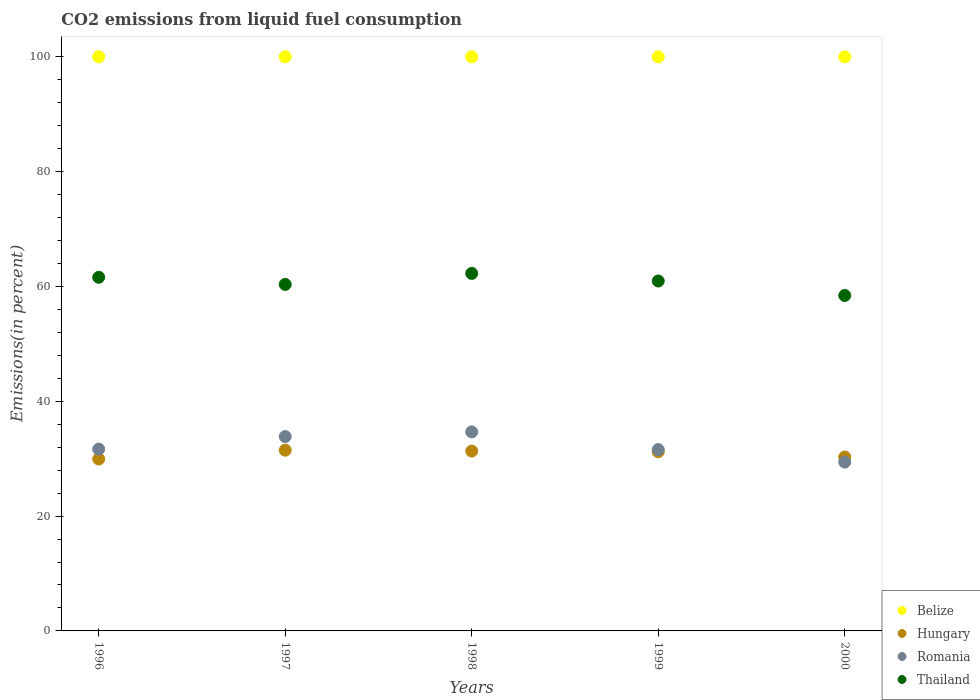Is the number of dotlines equal to the number of legend labels?
Your response must be concise. Yes. What is the total CO2 emitted in Thailand in 1996?
Your response must be concise. 61.6. In which year was the total CO2 emitted in Romania maximum?
Make the answer very short. 1998. What is the total total CO2 emitted in Thailand in the graph?
Make the answer very short. 303.62. What is the difference between the total CO2 emitted in Thailand in 1997 and that in 1999?
Your answer should be very brief. -0.59. What is the difference between the total CO2 emitted in Hungary in 1997 and the total CO2 emitted in Belize in 1996?
Make the answer very short. -68.52. In the year 1996, what is the difference between the total CO2 emitted in Romania and total CO2 emitted in Hungary?
Offer a very short reply. 1.72. What is the ratio of the total CO2 emitted in Thailand in 1999 to that in 2000?
Ensure brevity in your answer.  1.04. Is the total CO2 emitted in Thailand in 1999 less than that in 2000?
Provide a succinct answer. No. What is the difference between the highest and the second highest total CO2 emitted in Hungary?
Offer a terse response. 0.16. What is the difference between the highest and the lowest total CO2 emitted in Thailand?
Ensure brevity in your answer.  3.84. Is the sum of the total CO2 emitted in Belize in 1997 and 1998 greater than the maximum total CO2 emitted in Hungary across all years?
Provide a short and direct response. Yes. Is it the case that in every year, the sum of the total CO2 emitted in Hungary and total CO2 emitted in Thailand  is greater than the sum of total CO2 emitted in Romania and total CO2 emitted in Belize?
Your answer should be compact. Yes. Does the total CO2 emitted in Belize monotonically increase over the years?
Make the answer very short. No. Is the total CO2 emitted in Hungary strictly less than the total CO2 emitted in Thailand over the years?
Your answer should be compact. Yes. How many dotlines are there?
Give a very brief answer. 4. What is the difference between two consecutive major ticks on the Y-axis?
Ensure brevity in your answer.  20. Are the values on the major ticks of Y-axis written in scientific E-notation?
Offer a very short reply. No. Does the graph contain any zero values?
Give a very brief answer. No. Does the graph contain grids?
Provide a succinct answer. No. What is the title of the graph?
Your answer should be very brief. CO2 emissions from liquid fuel consumption. Does "Slovenia" appear as one of the legend labels in the graph?
Offer a very short reply. No. What is the label or title of the Y-axis?
Your answer should be very brief. Emissions(in percent). What is the Emissions(in percent) of Hungary in 1996?
Your answer should be compact. 29.95. What is the Emissions(in percent) in Romania in 1996?
Make the answer very short. 31.67. What is the Emissions(in percent) of Thailand in 1996?
Keep it short and to the point. 61.6. What is the Emissions(in percent) of Belize in 1997?
Make the answer very short. 100. What is the Emissions(in percent) of Hungary in 1997?
Your response must be concise. 31.48. What is the Emissions(in percent) of Romania in 1997?
Your answer should be very brief. 33.85. What is the Emissions(in percent) in Thailand in 1997?
Provide a short and direct response. 60.36. What is the Emissions(in percent) in Hungary in 1998?
Keep it short and to the point. 31.33. What is the Emissions(in percent) in Romania in 1998?
Offer a terse response. 34.67. What is the Emissions(in percent) in Thailand in 1998?
Provide a succinct answer. 62.27. What is the Emissions(in percent) in Belize in 1999?
Your answer should be compact. 100. What is the Emissions(in percent) in Hungary in 1999?
Make the answer very short. 31.21. What is the Emissions(in percent) in Romania in 1999?
Offer a very short reply. 31.59. What is the Emissions(in percent) of Thailand in 1999?
Keep it short and to the point. 60.95. What is the Emissions(in percent) in Belize in 2000?
Make the answer very short. 100. What is the Emissions(in percent) of Hungary in 2000?
Your response must be concise. 30.3. What is the Emissions(in percent) in Romania in 2000?
Give a very brief answer. 29.41. What is the Emissions(in percent) in Thailand in 2000?
Your answer should be very brief. 58.43. Across all years, what is the maximum Emissions(in percent) in Hungary?
Provide a short and direct response. 31.48. Across all years, what is the maximum Emissions(in percent) in Romania?
Keep it short and to the point. 34.67. Across all years, what is the maximum Emissions(in percent) in Thailand?
Give a very brief answer. 62.27. Across all years, what is the minimum Emissions(in percent) of Hungary?
Provide a short and direct response. 29.95. Across all years, what is the minimum Emissions(in percent) of Romania?
Your answer should be very brief. 29.41. Across all years, what is the minimum Emissions(in percent) of Thailand?
Your answer should be compact. 58.43. What is the total Emissions(in percent) of Hungary in the graph?
Ensure brevity in your answer.  154.27. What is the total Emissions(in percent) of Romania in the graph?
Keep it short and to the point. 161.19. What is the total Emissions(in percent) in Thailand in the graph?
Your answer should be compact. 303.62. What is the difference between the Emissions(in percent) in Hungary in 1996 and that in 1997?
Offer a very short reply. -1.54. What is the difference between the Emissions(in percent) in Romania in 1996 and that in 1997?
Provide a short and direct response. -2.19. What is the difference between the Emissions(in percent) in Thailand in 1996 and that in 1997?
Your answer should be compact. 1.24. What is the difference between the Emissions(in percent) of Belize in 1996 and that in 1998?
Give a very brief answer. 0. What is the difference between the Emissions(in percent) in Hungary in 1996 and that in 1998?
Ensure brevity in your answer.  -1.38. What is the difference between the Emissions(in percent) of Romania in 1996 and that in 1998?
Keep it short and to the point. -3. What is the difference between the Emissions(in percent) of Thailand in 1996 and that in 1998?
Offer a very short reply. -0.68. What is the difference between the Emissions(in percent) in Hungary in 1996 and that in 1999?
Your response must be concise. -1.27. What is the difference between the Emissions(in percent) of Romania in 1996 and that in 1999?
Offer a very short reply. 0.08. What is the difference between the Emissions(in percent) in Thailand in 1996 and that in 1999?
Your response must be concise. 0.65. What is the difference between the Emissions(in percent) of Hungary in 1996 and that in 2000?
Offer a very short reply. -0.35. What is the difference between the Emissions(in percent) of Romania in 1996 and that in 2000?
Make the answer very short. 2.26. What is the difference between the Emissions(in percent) of Thailand in 1996 and that in 2000?
Give a very brief answer. 3.17. What is the difference between the Emissions(in percent) in Belize in 1997 and that in 1998?
Make the answer very short. 0. What is the difference between the Emissions(in percent) of Hungary in 1997 and that in 1998?
Ensure brevity in your answer.  0.16. What is the difference between the Emissions(in percent) of Romania in 1997 and that in 1998?
Make the answer very short. -0.82. What is the difference between the Emissions(in percent) in Thailand in 1997 and that in 1998?
Keep it short and to the point. -1.92. What is the difference between the Emissions(in percent) of Belize in 1997 and that in 1999?
Your answer should be very brief. 0. What is the difference between the Emissions(in percent) in Hungary in 1997 and that in 1999?
Make the answer very short. 0.27. What is the difference between the Emissions(in percent) of Romania in 1997 and that in 1999?
Provide a succinct answer. 2.27. What is the difference between the Emissions(in percent) in Thailand in 1997 and that in 1999?
Ensure brevity in your answer.  -0.59. What is the difference between the Emissions(in percent) in Hungary in 1997 and that in 2000?
Provide a short and direct response. 1.19. What is the difference between the Emissions(in percent) of Romania in 1997 and that in 2000?
Make the answer very short. 4.44. What is the difference between the Emissions(in percent) in Thailand in 1997 and that in 2000?
Make the answer very short. 1.93. What is the difference between the Emissions(in percent) in Hungary in 1998 and that in 1999?
Give a very brief answer. 0.11. What is the difference between the Emissions(in percent) of Romania in 1998 and that in 1999?
Your answer should be compact. 3.09. What is the difference between the Emissions(in percent) of Thailand in 1998 and that in 1999?
Your answer should be very brief. 1.32. What is the difference between the Emissions(in percent) of Belize in 1998 and that in 2000?
Offer a terse response. 0. What is the difference between the Emissions(in percent) in Hungary in 1998 and that in 2000?
Your answer should be very brief. 1.03. What is the difference between the Emissions(in percent) in Romania in 1998 and that in 2000?
Your response must be concise. 5.26. What is the difference between the Emissions(in percent) in Thailand in 1998 and that in 2000?
Your response must be concise. 3.84. What is the difference between the Emissions(in percent) in Belize in 1999 and that in 2000?
Provide a short and direct response. 0. What is the difference between the Emissions(in percent) in Hungary in 1999 and that in 2000?
Your answer should be compact. 0.92. What is the difference between the Emissions(in percent) of Romania in 1999 and that in 2000?
Offer a very short reply. 2.17. What is the difference between the Emissions(in percent) of Thailand in 1999 and that in 2000?
Your answer should be compact. 2.52. What is the difference between the Emissions(in percent) in Belize in 1996 and the Emissions(in percent) in Hungary in 1997?
Provide a succinct answer. 68.52. What is the difference between the Emissions(in percent) in Belize in 1996 and the Emissions(in percent) in Romania in 1997?
Offer a very short reply. 66.15. What is the difference between the Emissions(in percent) of Belize in 1996 and the Emissions(in percent) of Thailand in 1997?
Offer a terse response. 39.64. What is the difference between the Emissions(in percent) in Hungary in 1996 and the Emissions(in percent) in Romania in 1997?
Make the answer very short. -3.91. What is the difference between the Emissions(in percent) in Hungary in 1996 and the Emissions(in percent) in Thailand in 1997?
Keep it short and to the point. -30.41. What is the difference between the Emissions(in percent) in Romania in 1996 and the Emissions(in percent) in Thailand in 1997?
Provide a succinct answer. -28.69. What is the difference between the Emissions(in percent) of Belize in 1996 and the Emissions(in percent) of Hungary in 1998?
Give a very brief answer. 68.67. What is the difference between the Emissions(in percent) of Belize in 1996 and the Emissions(in percent) of Romania in 1998?
Offer a terse response. 65.33. What is the difference between the Emissions(in percent) in Belize in 1996 and the Emissions(in percent) in Thailand in 1998?
Provide a short and direct response. 37.73. What is the difference between the Emissions(in percent) of Hungary in 1996 and the Emissions(in percent) of Romania in 1998?
Your response must be concise. -4.73. What is the difference between the Emissions(in percent) of Hungary in 1996 and the Emissions(in percent) of Thailand in 1998?
Make the answer very short. -32.33. What is the difference between the Emissions(in percent) of Romania in 1996 and the Emissions(in percent) of Thailand in 1998?
Your answer should be very brief. -30.61. What is the difference between the Emissions(in percent) in Belize in 1996 and the Emissions(in percent) in Hungary in 1999?
Your answer should be compact. 68.79. What is the difference between the Emissions(in percent) in Belize in 1996 and the Emissions(in percent) in Romania in 1999?
Give a very brief answer. 68.41. What is the difference between the Emissions(in percent) of Belize in 1996 and the Emissions(in percent) of Thailand in 1999?
Provide a succinct answer. 39.05. What is the difference between the Emissions(in percent) of Hungary in 1996 and the Emissions(in percent) of Romania in 1999?
Provide a short and direct response. -1.64. What is the difference between the Emissions(in percent) of Hungary in 1996 and the Emissions(in percent) of Thailand in 1999?
Ensure brevity in your answer.  -31.01. What is the difference between the Emissions(in percent) of Romania in 1996 and the Emissions(in percent) of Thailand in 1999?
Your response must be concise. -29.29. What is the difference between the Emissions(in percent) in Belize in 1996 and the Emissions(in percent) in Hungary in 2000?
Provide a succinct answer. 69.7. What is the difference between the Emissions(in percent) in Belize in 1996 and the Emissions(in percent) in Romania in 2000?
Offer a terse response. 70.59. What is the difference between the Emissions(in percent) in Belize in 1996 and the Emissions(in percent) in Thailand in 2000?
Your answer should be very brief. 41.57. What is the difference between the Emissions(in percent) of Hungary in 1996 and the Emissions(in percent) of Romania in 2000?
Provide a succinct answer. 0.54. What is the difference between the Emissions(in percent) of Hungary in 1996 and the Emissions(in percent) of Thailand in 2000?
Keep it short and to the point. -28.49. What is the difference between the Emissions(in percent) in Romania in 1996 and the Emissions(in percent) in Thailand in 2000?
Keep it short and to the point. -26.76. What is the difference between the Emissions(in percent) in Belize in 1997 and the Emissions(in percent) in Hungary in 1998?
Keep it short and to the point. 68.67. What is the difference between the Emissions(in percent) in Belize in 1997 and the Emissions(in percent) in Romania in 1998?
Make the answer very short. 65.33. What is the difference between the Emissions(in percent) in Belize in 1997 and the Emissions(in percent) in Thailand in 1998?
Give a very brief answer. 37.73. What is the difference between the Emissions(in percent) in Hungary in 1997 and the Emissions(in percent) in Romania in 1998?
Provide a succinct answer. -3.19. What is the difference between the Emissions(in percent) in Hungary in 1997 and the Emissions(in percent) in Thailand in 1998?
Your answer should be very brief. -30.79. What is the difference between the Emissions(in percent) of Romania in 1997 and the Emissions(in percent) of Thailand in 1998?
Your response must be concise. -28.42. What is the difference between the Emissions(in percent) of Belize in 1997 and the Emissions(in percent) of Hungary in 1999?
Offer a very short reply. 68.79. What is the difference between the Emissions(in percent) of Belize in 1997 and the Emissions(in percent) of Romania in 1999?
Offer a very short reply. 68.41. What is the difference between the Emissions(in percent) of Belize in 1997 and the Emissions(in percent) of Thailand in 1999?
Your answer should be compact. 39.05. What is the difference between the Emissions(in percent) of Hungary in 1997 and the Emissions(in percent) of Romania in 1999?
Your answer should be very brief. -0.1. What is the difference between the Emissions(in percent) in Hungary in 1997 and the Emissions(in percent) in Thailand in 1999?
Ensure brevity in your answer.  -29.47. What is the difference between the Emissions(in percent) of Romania in 1997 and the Emissions(in percent) of Thailand in 1999?
Make the answer very short. -27.1. What is the difference between the Emissions(in percent) in Belize in 1997 and the Emissions(in percent) in Hungary in 2000?
Your answer should be very brief. 69.7. What is the difference between the Emissions(in percent) in Belize in 1997 and the Emissions(in percent) in Romania in 2000?
Provide a short and direct response. 70.59. What is the difference between the Emissions(in percent) in Belize in 1997 and the Emissions(in percent) in Thailand in 2000?
Offer a terse response. 41.57. What is the difference between the Emissions(in percent) in Hungary in 1997 and the Emissions(in percent) in Romania in 2000?
Provide a short and direct response. 2.07. What is the difference between the Emissions(in percent) in Hungary in 1997 and the Emissions(in percent) in Thailand in 2000?
Keep it short and to the point. -26.95. What is the difference between the Emissions(in percent) of Romania in 1997 and the Emissions(in percent) of Thailand in 2000?
Ensure brevity in your answer.  -24.58. What is the difference between the Emissions(in percent) of Belize in 1998 and the Emissions(in percent) of Hungary in 1999?
Provide a short and direct response. 68.79. What is the difference between the Emissions(in percent) in Belize in 1998 and the Emissions(in percent) in Romania in 1999?
Your answer should be compact. 68.41. What is the difference between the Emissions(in percent) in Belize in 1998 and the Emissions(in percent) in Thailand in 1999?
Ensure brevity in your answer.  39.05. What is the difference between the Emissions(in percent) in Hungary in 1998 and the Emissions(in percent) in Romania in 1999?
Give a very brief answer. -0.26. What is the difference between the Emissions(in percent) of Hungary in 1998 and the Emissions(in percent) of Thailand in 1999?
Offer a terse response. -29.63. What is the difference between the Emissions(in percent) of Romania in 1998 and the Emissions(in percent) of Thailand in 1999?
Offer a very short reply. -26.28. What is the difference between the Emissions(in percent) in Belize in 1998 and the Emissions(in percent) in Hungary in 2000?
Ensure brevity in your answer.  69.7. What is the difference between the Emissions(in percent) of Belize in 1998 and the Emissions(in percent) of Romania in 2000?
Your answer should be very brief. 70.59. What is the difference between the Emissions(in percent) in Belize in 1998 and the Emissions(in percent) in Thailand in 2000?
Your response must be concise. 41.57. What is the difference between the Emissions(in percent) in Hungary in 1998 and the Emissions(in percent) in Romania in 2000?
Your answer should be compact. 1.91. What is the difference between the Emissions(in percent) of Hungary in 1998 and the Emissions(in percent) of Thailand in 2000?
Make the answer very short. -27.11. What is the difference between the Emissions(in percent) of Romania in 1998 and the Emissions(in percent) of Thailand in 2000?
Make the answer very short. -23.76. What is the difference between the Emissions(in percent) in Belize in 1999 and the Emissions(in percent) in Hungary in 2000?
Your answer should be compact. 69.7. What is the difference between the Emissions(in percent) in Belize in 1999 and the Emissions(in percent) in Romania in 2000?
Provide a short and direct response. 70.59. What is the difference between the Emissions(in percent) in Belize in 1999 and the Emissions(in percent) in Thailand in 2000?
Offer a very short reply. 41.57. What is the difference between the Emissions(in percent) of Hungary in 1999 and the Emissions(in percent) of Romania in 2000?
Keep it short and to the point. 1.8. What is the difference between the Emissions(in percent) in Hungary in 1999 and the Emissions(in percent) in Thailand in 2000?
Your response must be concise. -27.22. What is the difference between the Emissions(in percent) in Romania in 1999 and the Emissions(in percent) in Thailand in 2000?
Provide a short and direct response. -26.85. What is the average Emissions(in percent) of Belize per year?
Your answer should be compact. 100. What is the average Emissions(in percent) in Hungary per year?
Provide a succinct answer. 30.85. What is the average Emissions(in percent) of Romania per year?
Provide a succinct answer. 32.24. What is the average Emissions(in percent) in Thailand per year?
Offer a very short reply. 60.72. In the year 1996, what is the difference between the Emissions(in percent) of Belize and Emissions(in percent) of Hungary?
Provide a short and direct response. 70.05. In the year 1996, what is the difference between the Emissions(in percent) of Belize and Emissions(in percent) of Romania?
Provide a succinct answer. 68.33. In the year 1996, what is the difference between the Emissions(in percent) of Belize and Emissions(in percent) of Thailand?
Offer a very short reply. 38.4. In the year 1996, what is the difference between the Emissions(in percent) in Hungary and Emissions(in percent) in Romania?
Your answer should be very brief. -1.72. In the year 1996, what is the difference between the Emissions(in percent) of Hungary and Emissions(in percent) of Thailand?
Your answer should be very brief. -31.65. In the year 1996, what is the difference between the Emissions(in percent) of Romania and Emissions(in percent) of Thailand?
Your response must be concise. -29.93. In the year 1997, what is the difference between the Emissions(in percent) of Belize and Emissions(in percent) of Hungary?
Provide a short and direct response. 68.52. In the year 1997, what is the difference between the Emissions(in percent) of Belize and Emissions(in percent) of Romania?
Keep it short and to the point. 66.15. In the year 1997, what is the difference between the Emissions(in percent) of Belize and Emissions(in percent) of Thailand?
Offer a terse response. 39.64. In the year 1997, what is the difference between the Emissions(in percent) of Hungary and Emissions(in percent) of Romania?
Your answer should be compact. -2.37. In the year 1997, what is the difference between the Emissions(in percent) of Hungary and Emissions(in percent) of Thailand?
Your response must be concise. -28.87. In the year 1997, what is the difference between the Emissions(in percent) in Romania and Emissions(in percent) in Thailand?
Your response must be concise. -26.5. In the year 1998, what is the difference between the Emissions(in percent) of Belize and Emissions(in percent) of Hungary?
Your answer should be very brief. 68.67. In the year 1998, what is the difference between the Emissions(in percent) in Belize and Emissions(in percent) in Romania?
Provide a short and direct response. 65.33. In the year 1998, what is the difference between the Emissions(in percent) of Belize and Emissions(in percent) of Thailand?
Offer a terse response. 37.73. In the year 1998, what is the difference between the Emissions(in percent) in Hungary and Emissions(in percent) in Romania?
Ensure brevity in your answer.  -3.35. In the year 1998, what is the difference between the Emissions(in percent) in Hungary and Emissions(in percent) in Thailand?
Keep it short and to the point. -30.95. In the year 1998, what is the difference between the Emissions(in percent) of Romania and Emissions(in percent) of Thailand?
Give a very brief answer. -27.6. In the year 1999, what is the difference between the Emissions(in percent) in Belize and Emissions(in percent) in Hungary?
Your answer should be very brief. 68.79. In the year 1999, what is the difference between the Emissions(in percent) of Belize and Emissions(in percent) of Romania?
Provide a short and direct response. 68.41. In the year 1999, what is the difference between the Emissions(in percent) in Belize and Emissions(in percent) in Thailand?
Ensure brevity in your answer.  39.05. In the year 1999, what is the difference between the Emissions(in percent) of Hungary and Emissions(in percent) of Romania?
Offer a terse response. -0.37. In the year 1999, what is the difference between the Emissions(in percent) in Hungary and Emissions(in percent) in Thailand?
Your response must be concise. -29.74. In the year 1999, what is the difference between the Emissions(in percent) of Romania and Emissions(in percent) of Thailand?
Make the answer very short. -29.37. In the year 2000, what is the difference between the Emissions(in percent) of Belize and Emissions(in percent) of Hungary?
Give a very brief answer. 69.7. In the year 2000, what is the difference between the Emissions(in percent) in Belize and Emissions(in percent) in Romania?
Make the answer very short. 70.59. In the year 2000, what is the difference between the Emissions(in percent) of Belize and Emissions(in percent) of Thailand?
Provide a short and direct response. 41.57. In the year 2000, what is the difference between the Emissions(in percent) of Hungary and Emissions(in percent) of Romania?
Offer a very short reply. 0.89. In the year 2000, what is the difference between the Emissions(in percent) in Hungary and Emissions(in percent) in Thailand?
Provide a short and direct response. -28.14. In the year 2000, what is the difference between the Emissions(in percent) of Romania and Emissions(in percent) of Thailand?
Make the answer very short. -29.02. What is the ratio of the Emissions(in percent) in Belize in 1996 to that in 1997?
Your answer should be compact. 1. What is the ratio of the Emissions(in percent) of Hungary in 1996 to that in 1997?
Your answer should be very brief. 0.95. What is the ratio of the Emissions(in percent) in Romania in 1996 to that in 1997?
Ensure brevity in your answer.  0.94. What is the ratio of the Emissions(in percent) in Thailand in 1996 to that in 1997?
Keep it short and to the point. 1.02. What is the ratio of the Emissions(in percent) in Hungary in 1996 to that in 1998?
Ensure brevity in your answer.  0.96. What is the ratio of the Emissions(in percent) in Romania in 1996 to that in 1998?
Provide a succinct answer. 0.91. What is the ratio of the Emissions(in percent) of Thailand in 1996 to that in 1998?
Keep it short and to the point. 0.99. What is the ratio of the Emissions(in percent) of Hungary in 1996 to that in 1999?
Make the answer very short. 0.96. What is the ratio of the Emissions(in percent) of Thailand in 1996 to that in 1999?
Offer a terse response. 1.01. What is the ratio of the Emissions(in percent) of Belize in 1996 to that in 2000?
Your response must be concise. 1. What is the ratio of the Emissions(in percent) in Hungary in 1996 to that in 2000?
Offer a terse response. 0.99. What is the ratio of the Emissions(in percent) in Romania in 1996 to that in 2000?
Provide a short and direct response. 1.08. What is the ratio of the Emissions(in percent) in Thailand in 1996 to that in 2000?
Provide a short and direct response. 1.05. What is the ratio of the Emissions(in percent) in Romania in 1997 to that in 1998?
Give a very brief answer. 0.98. What is the ratio of the Emissions(in percent) in Thailand in 1997 to that in 1998?
Ensure brevity in your answer.  0.97. What is the ratio of the Emissions(in percent) of Belize in 1997 to that in 1999?
Offer a terse response. 1. What is the ratio of the Emissions(in percent) of Hungary in 1997 to that in 1999?
Your answer should be compact. 1.01. What is the ratio of the Emissions(in percent) in Romania in 1997 to that in 1999?
Offer a very short reply. 1.07. What is the ratio of the Emissions(in percent) of Thailand in 1997 to that in 1999?
Keep it short and to the point. 0.99. What is the ratio of the Emissions(in percent) of Hungary in 1997 to that in 2000?
Ensure brevity in your answer.  1.04. What is the ratio of the Emissions(in percent) of Romania in 1997 to that in 2000?
Give a very brief answer. 1.15. What is the ratio of the Emissions(in percent) of Thailand in 1997 to that in 2000?
Give a very brief answer. 1.03. What is the ratio of the Emissions(in percent) in Belize in 1998 to that in 1999?
Provide a succinct answer. 1. What is the ratio of the Emissions(in percent) of Romania in 1998 to that in 1999?
Keep it short and to the point. 1.1. What is the ratio of the Emissions(in percent) in Thailand in 1998 to that in 1999?
Offer a terse response. 1.02. What is the ratio of the Emissions(in percent) of Belize in 1998 to that in 2000?
Provide a succinct answer. 1. What is the ratio of the Emissions(in percent) in Hungary in 1998 to that in 2000?
Offer a terse response. 1.03. What is the ratio of the Emissions(in percent) of Romania in 1998 to that in 2000?
Your answer should be very brief. 1.18. What is the ratio of the Emissions(in percent) of Thailand in 1998 to that in 2000?
Your answer should be compact. 1.07. What is the ratio of the Emissions(in percent) in Hungary in 1999 to that in 2000?
Ensure brevity in your answer.  1.03. What is the ratio of the Emissions(in percent) of Romania in 1999 to that in 2000?
Give a very brief answer. 1.07. What is the ratio of the Emissions(in percent) in Thailand in 1999 to that in 2000?
Ensure brevity in your answer.  1.04. What is the difference between the highest and the second highest Emissions(in percent) in Belize?
Ensure brevity in your answer.  0. What is the difference between the highest and the second highest Emissions(in percent) in Hungary?
Your answer should be very brief. 0.16. What is the difference between the highest and the second highest Emissions(in percent) of Romania?
Keep it short and to the point. 0.82. What is the difference between the highest and the second highest Emissions(in percent) in Thailand?
Ensure brevity in your answer.  0.68. What is the difference between the highest and the lowest Emissions(in percent) of Hungary?
Make the answer very short. 1.54. What is the difference between the highest and the lowest Emissions(in percent) in Romania?
Offer a terse response. 5.26. What is the difference between the highest and the lowest Emissions(in percent) of Thailand?
Keep it short and to the point. 3.84. 